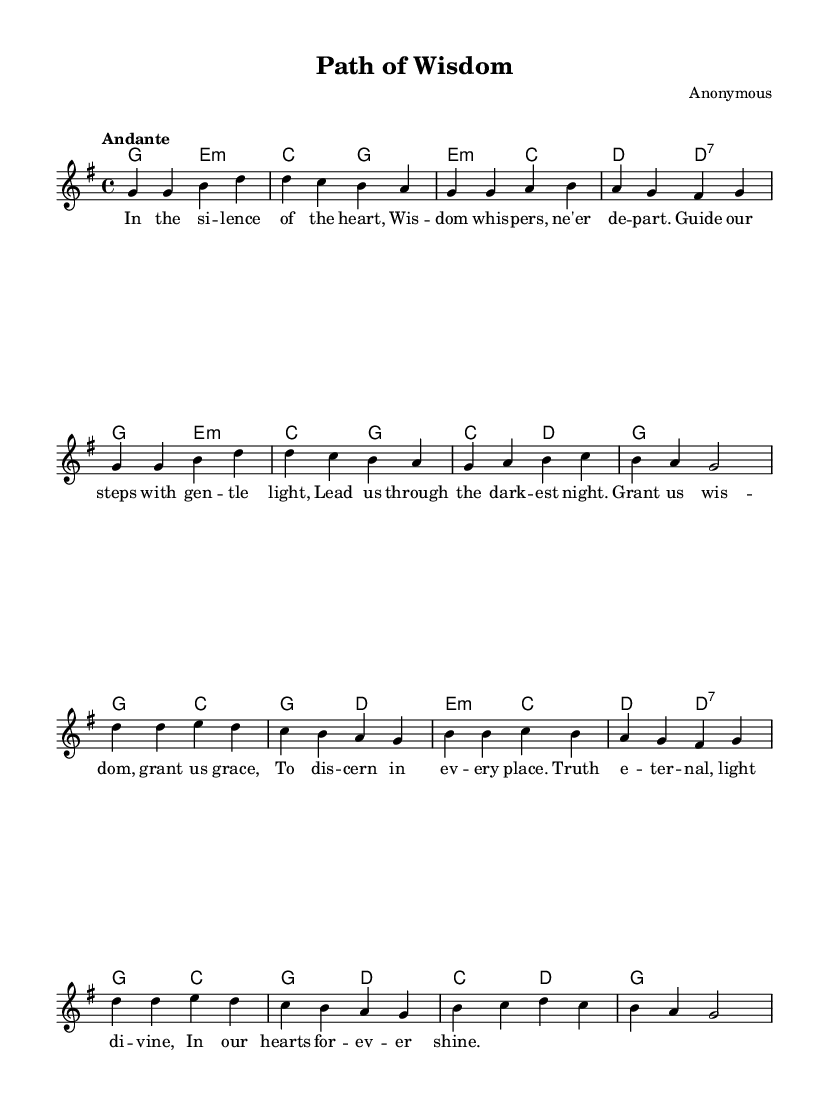What is the key signature of this music? The key signature is G major, which has one sharp (F#). This can be identified from the key specified at the beginning of the score.
Answer: G major What is the time signature indicated in the sheet music? The time signature is 4/4, which is typically notated at the start of the score. This means there are four beats in each measure.
Answer: 4/4 What is the tempo marking for this piece? The tempo marking is "Andante", which is a term indicating a walking pace. It is set at the beginning of the score under the tempo instruction.
Answer: Andante How many verses are included in this piece? There is one verse in this piece, as indicated by the structure of the score, which includes a single set of lyrics before the chorus.
Answer: One What are the main themes presented in the lyrics? The main themes include wisdom and discernment, as articulated through the lyrics that express a desire for guidance and enlightenment. These themes can be inferred from the lyrical content and overall tone.
Answer: Wisdom and discernment What is the first lyric of the song? The first lyric is "In the si - lence of the heart," and it introduces the reflective and spiritual nature of the piece. The lyrics are clearly laid out in the lyric mode of the code.
Answer: In the si - lence of the heart What type of music is this piece classified as? This piece is classified as traditional religious folk music. The lyrics and themes center around spiritual concepts and wisdom, which are characteristic of this genre.
Answer: Traditional religious folk music 